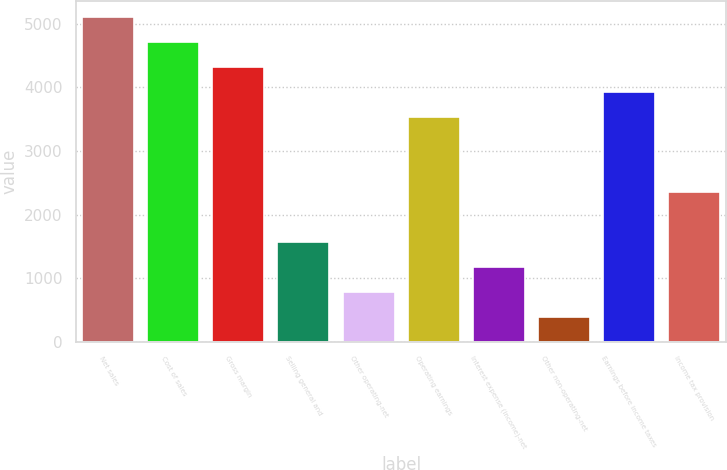Convert chart. <chart><loc_0><loc_0><loc_500><loc_500><bar_chart><fcel>Net sales<fcel>Cost of sales<fcel>Gross margin<fcel>Selling general and<fcel>Other operating-net<fcel>Operating earnings<fcel>Interest expense (income)-net<fcel>Other non-operating-net<fcel>Earnings before income taxes<fcel>Income tax provision<nl><fcel>5097.31<fcel>4705.24<fcel>4313.17<fcel>1568.68<fcel>784.54<fcel>3529.03<fcel>1176.61<fcel>392.47<fcel>3921.1<fcel>2352.82<nl></chart> 